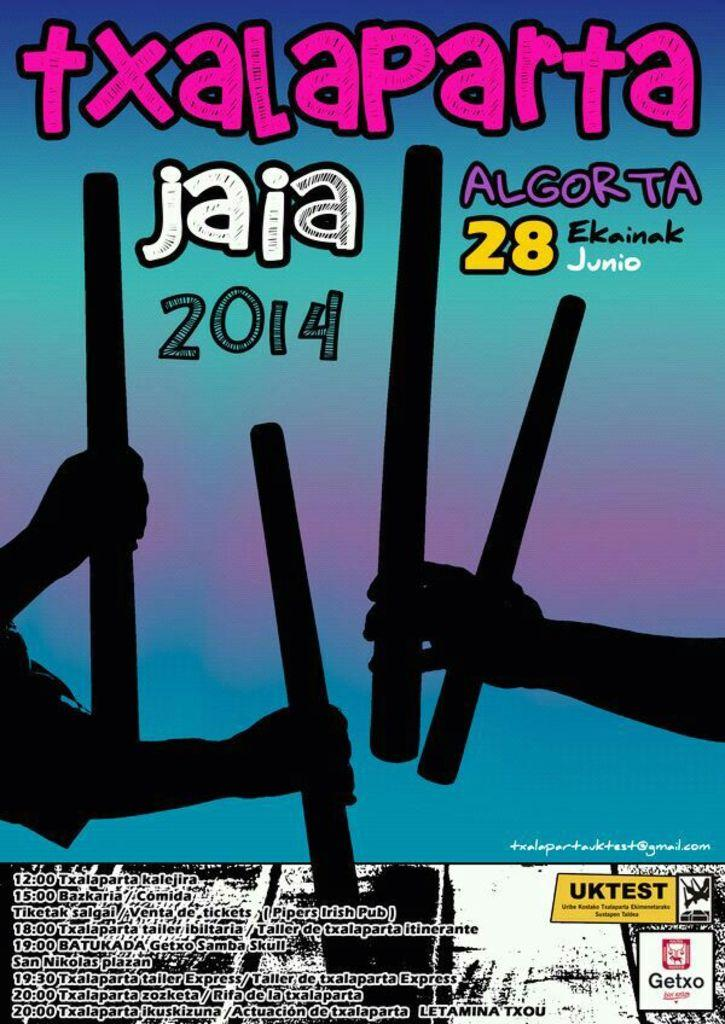<image>
Create a compact narrative representing the image presented. A poster in a foreign language featuring hands holding sticks from 2014 